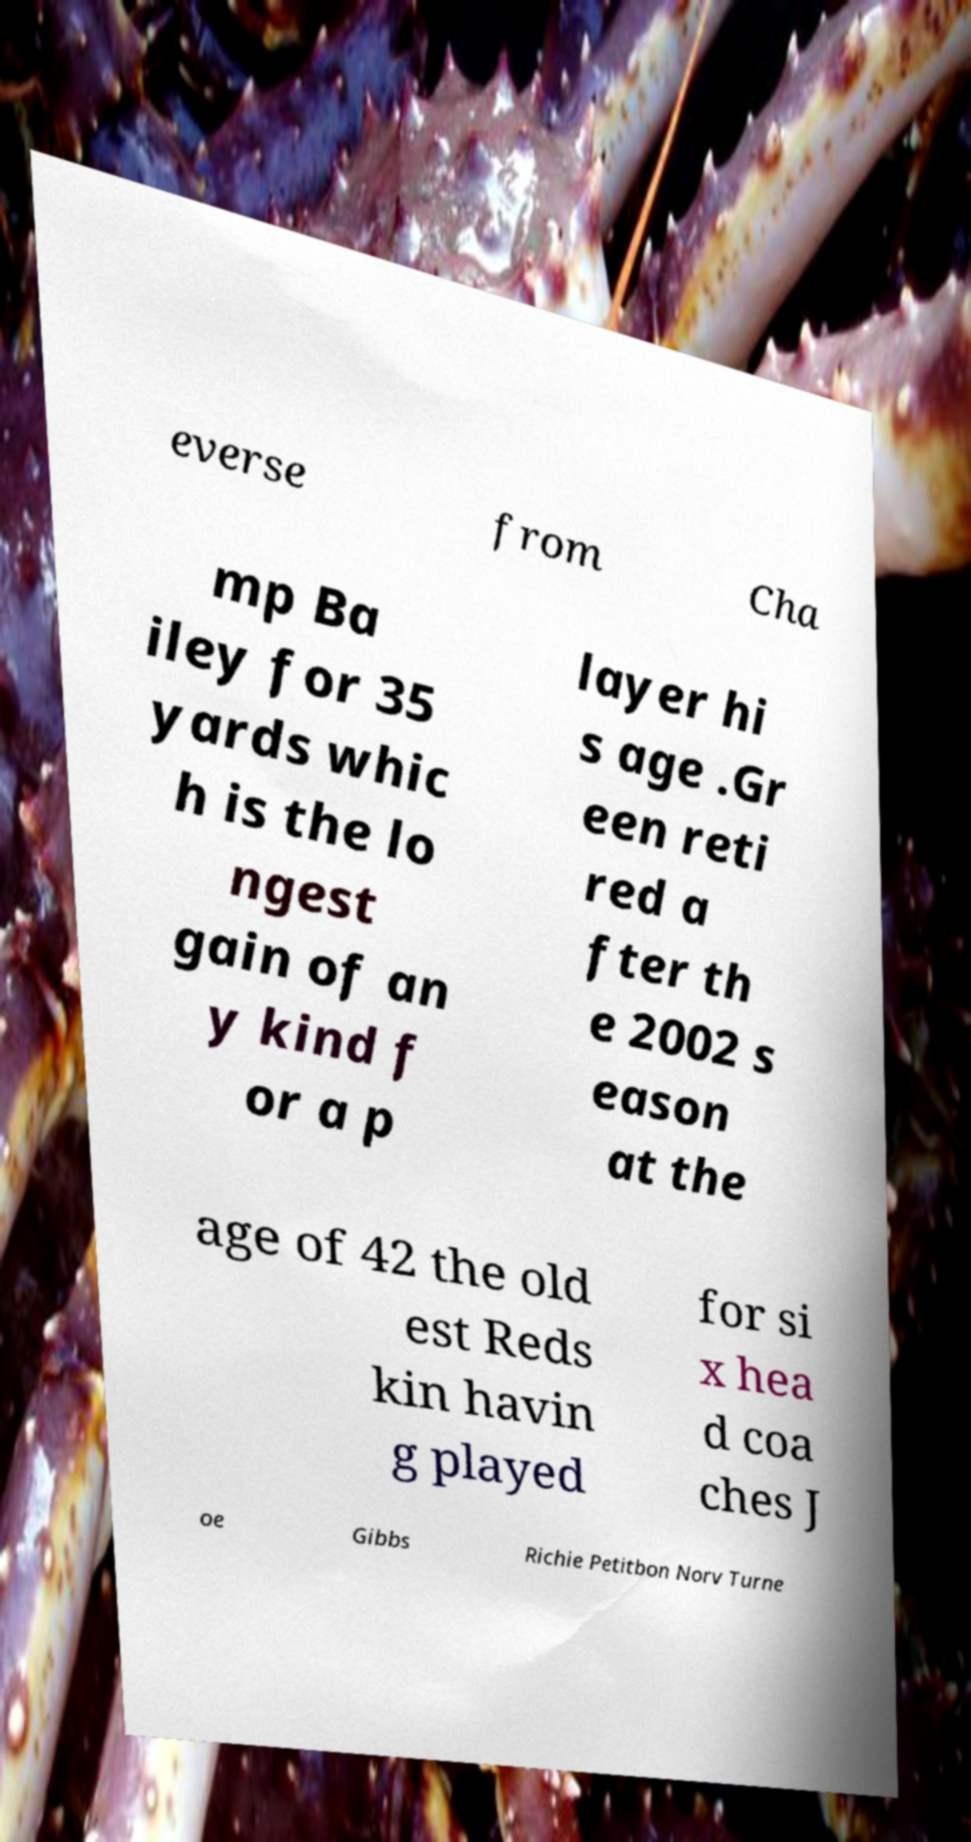I need the written content from this picture converted into text. Can you do that? everse from Cha mp Ba iley for 35 yards whic h is the lo ngest gain of an y kind f or a p layer hi s age .Gr een reti red a fter th e 2002 s eason at the age of 42 the old est Reds kin havin g played for si x hea d coa ches J oe Gibbs Richie Petitbon Norv Turne 